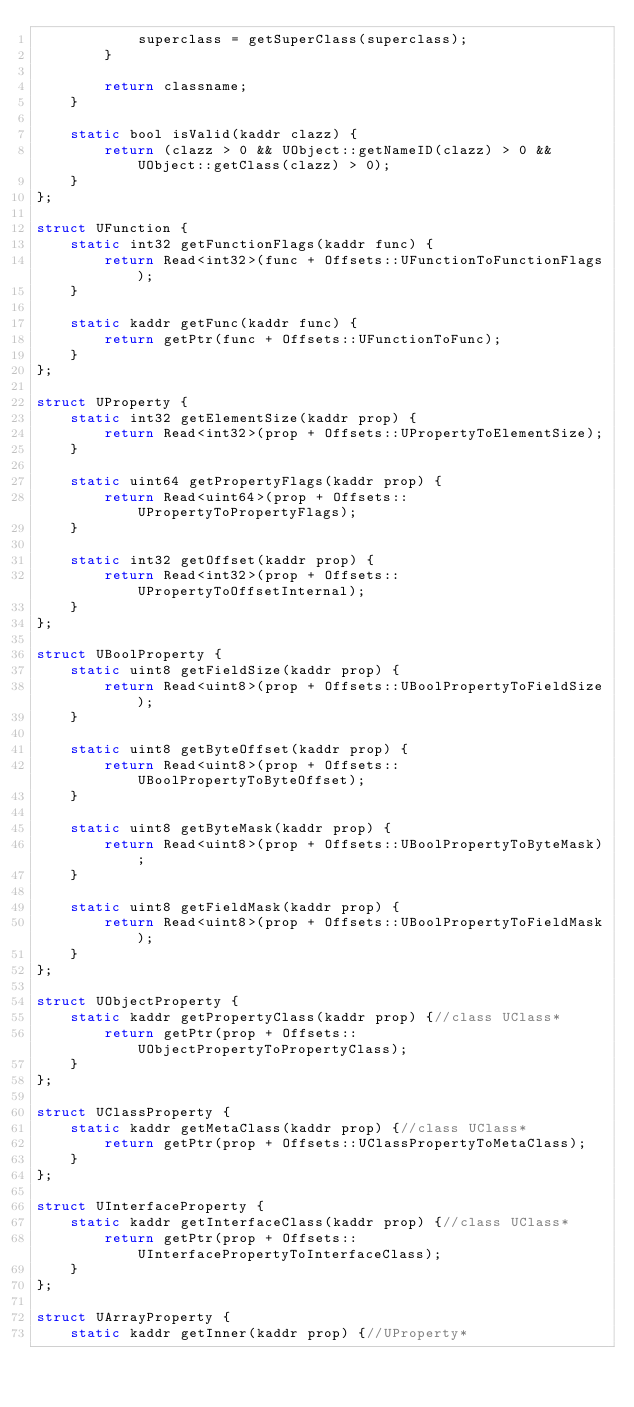Convert code to text. <code><loc_0><loc_0><loc_500><loc_500><_C_>            superclass = getSuperClass(superclass);
        }

        return classname;
    }

    static bool isValid(kaddr clazz) {
        return (clazz > 0 && UObject::getNameID(clazz) > 0 && UObject::getClass(clazz) > 0);
    }
};

struct UFunction {
    static int32 getFunctionFlags(kaddr func) {
        return Read<int32>(func + Offsets::UFunctionToFunctionFlags);
    }

    static kaddr getFunc(kaddr func) {
        return getPtr(func + Offsets::UFunctionToFunc);
    }
};

struct UProperty {
    static int32 getElementSize(kaddr prop) {
        return Read<int32>(prop + Offsets::UPropertyToElementSize);
    }

    static uint64 getPropertyFlags(kaddr prop) {
        return Read<uint64>(prop + Offsets::UPropertyToPropertyFlags);
    }

    static int32 getOffset(kaddr prop) {
        return Read<int32>(prop + Offsets::UPropertyToOffsetInternal);
    }
};

struct UBoolProperty {
    static uint8 getFieldSize(kaddr prop) {
        return Read<uint8>(prop + Offsets::UBoolPropertyToFieldSize);
    }

    static uint8 getByteOffset(kaddr prop) {
        return Read<uint8>(prop + Offsets::UBoolPropertyToByteOffset);
    }

    static uint8 getByteMask(kaddr prop) {
        return Read<uint8>(prop + Offsets::UBoolPropertyToByteMask);
    }

    static uint8 getFieldMask(kaddr prop) {
        return Read<uint8>(prop + Offsets::UBoolPropertyToFieldMask);
    }
};

struct UObjectProperty {
    static kaddr getPropertyClass(kaddr prop) {//class UClass*
        return getPtr(prop + Offsets::UObjectPropertyToPropertyClass);
    }
};

struct UClassProperty {
    static kaddr getMetaClass(kaddr prop) {//class UClass*
        return getPtr(prop + Offsets::UClassPropertyToMetaClass);
    }
};

struct UInterfaceProperty {
    static kaddr getInterfaceClass(kaddr prop) {//class UClass*
        return getPtr(prop + Offsets::UInterfacePropertyToInterfaceClass);
    }
};

struct UArrayProperty {
    static kaddr getInner(kaddr prop) {//UProperty*</code> 